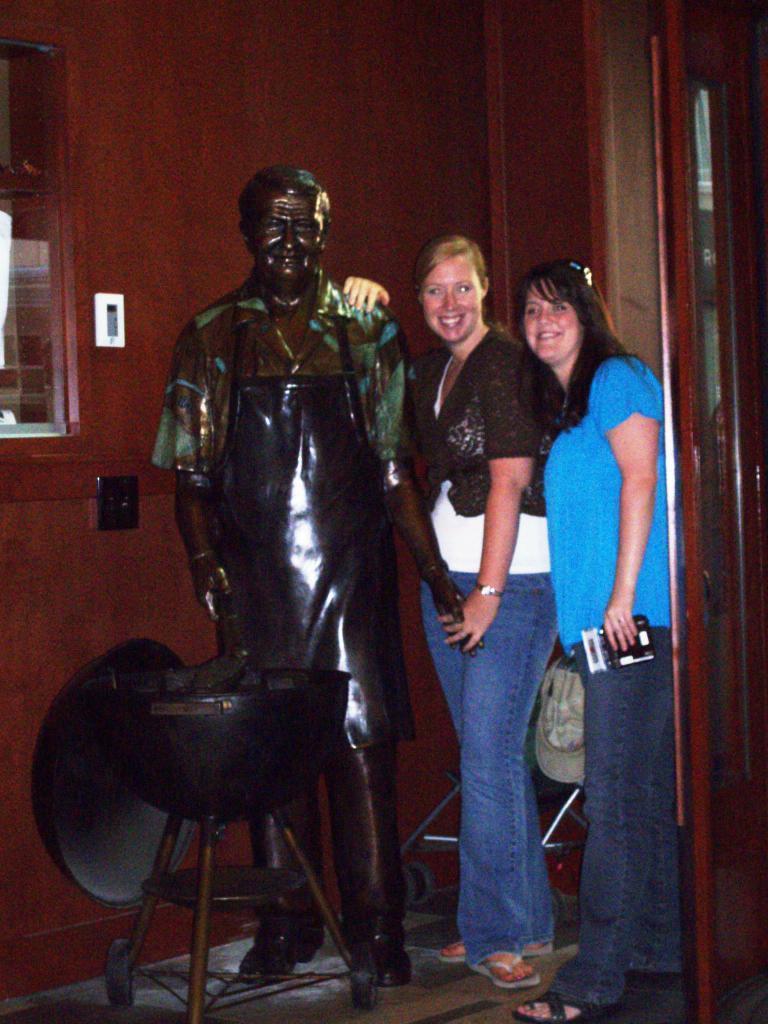In one or two sentences, can you explain what this image depicts? In the center of a picture there are two women near a statue. On the left there is a bowl like object and window at the top. On the right it is door. In the background it is wall painted white. 